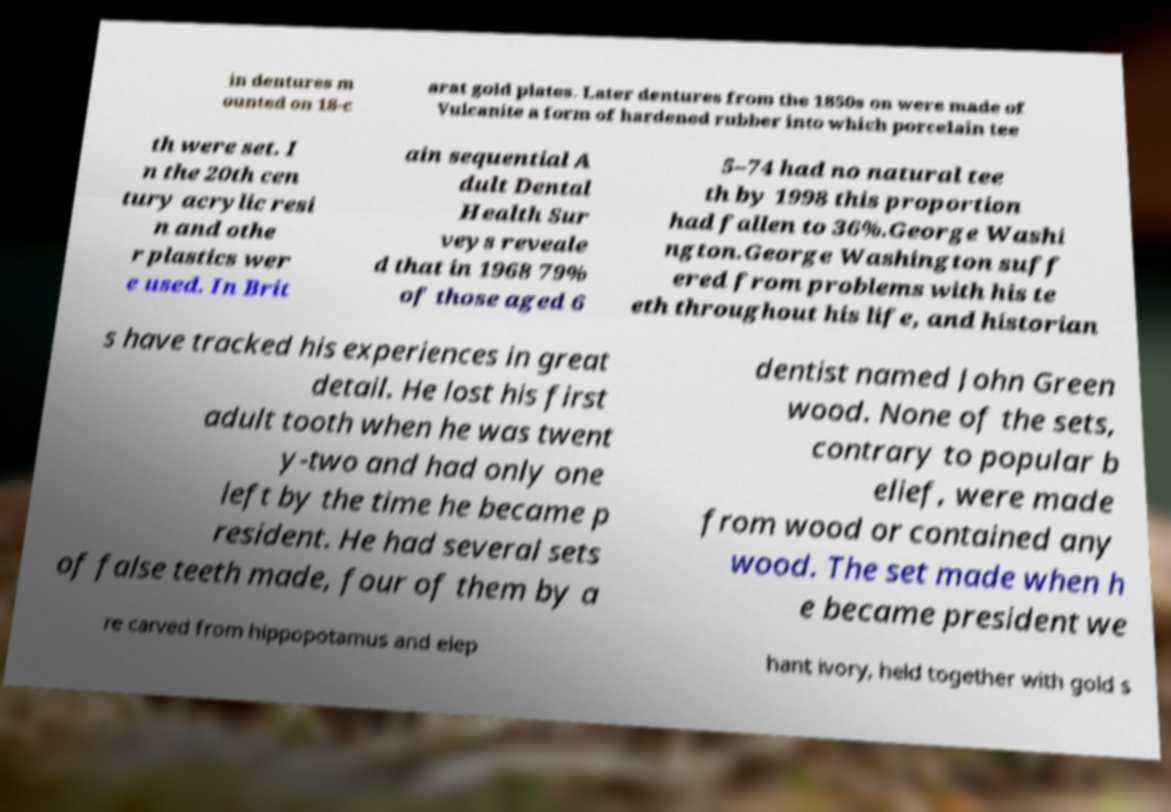Can you read and provide the text displayed in the image?This photo seems to have some interesting text. Can you extract and type it out for me? in dentures m ounted on 18-c arat gold plates. Later dentures from the 1850s on were made of Vulcanite a form of hardened rubber into which porcelain tee th were set. I n the 20th cen tury acrylic resi n and othe r plastics wer e used. In Brit ain sequential A dult Dental Health Sur veys reveale d that in 1968 79% of those aged 6 5–74 had no natural tee th by 1998 this proportion had fallen to 36%.George Washi ngton.George Washington suff ered from problems with his te eth throughout his life, and historian s have tracked his experiences in great detail. He lost his first adult tooth when he was twent y-two and had only one left by the time he became p resident. He had several sets of false teeth made, four of them by a dentist named John Green wood. None of the sets, contrary to popular b elief, were made from wood or contained any wood. The set made when h e became president we re carved from hippopotamus and elep hant ivory, held together with gold s 